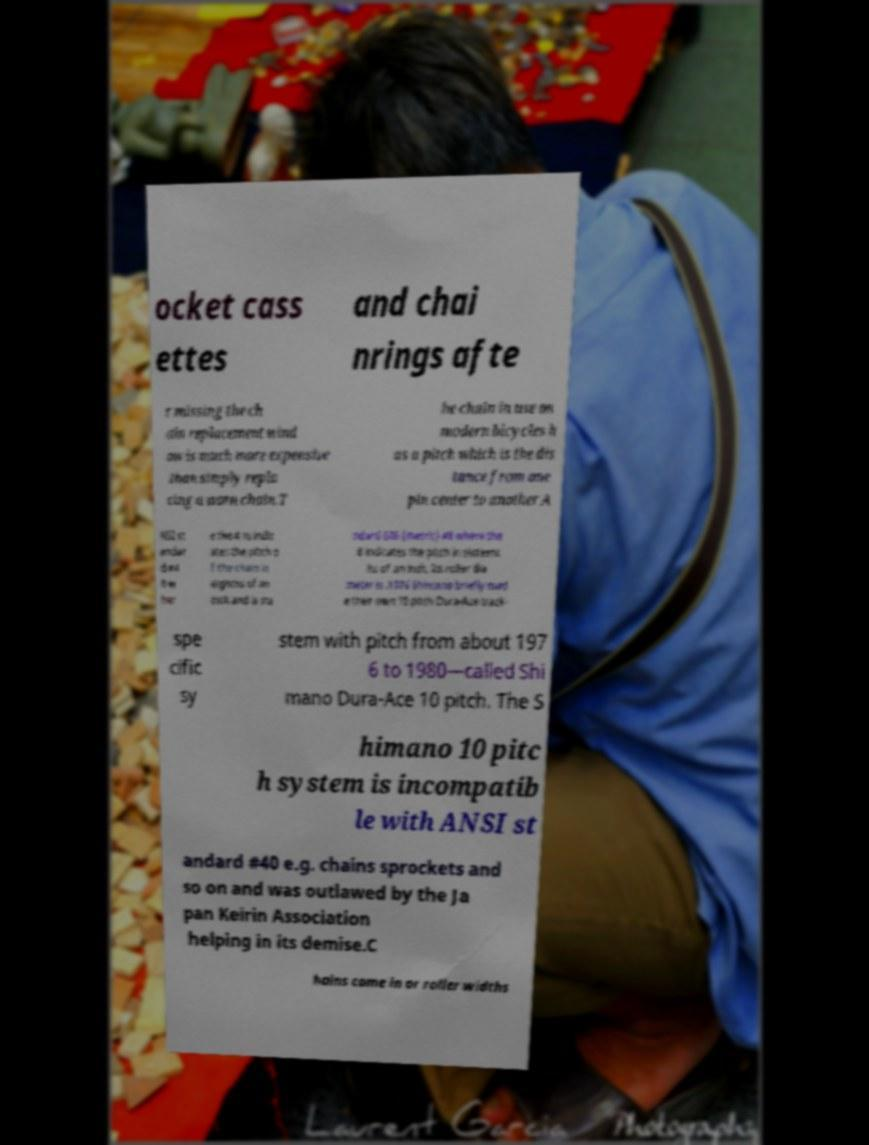Please read and relay the text visible in this image. What does it say? ocket cass ettes and chai nrings afte r missing the ch ain replacement wind ow is much more expensive than simply repla cing a worn chain.T he chain in use on modern bicycles h as a pitch which is the dis tance from one pin center to another A NSI st andar d #4 0 w her e the 4 in indic ates the pitch o f the chain in eighths of an inch and is sta ndard 606 (metric) #8 where the 8 indicates the pitch in sixteent hs of an inch. Its roller dia meter is .1976 Shimano briefly mad e their own 10 pitch Dura-Ace track- spe cific sy stem with pitch from about 197 6 to 1980—called Shi mano Dura-Ace 10 pitch. The S himano 10 pitc h system is incompatib le with ANSI st andard #40 e.g. chains sprockets and so on and was outlawed by the Ja pan Keirin Association helping in its demise.C hains come in or roller widths 